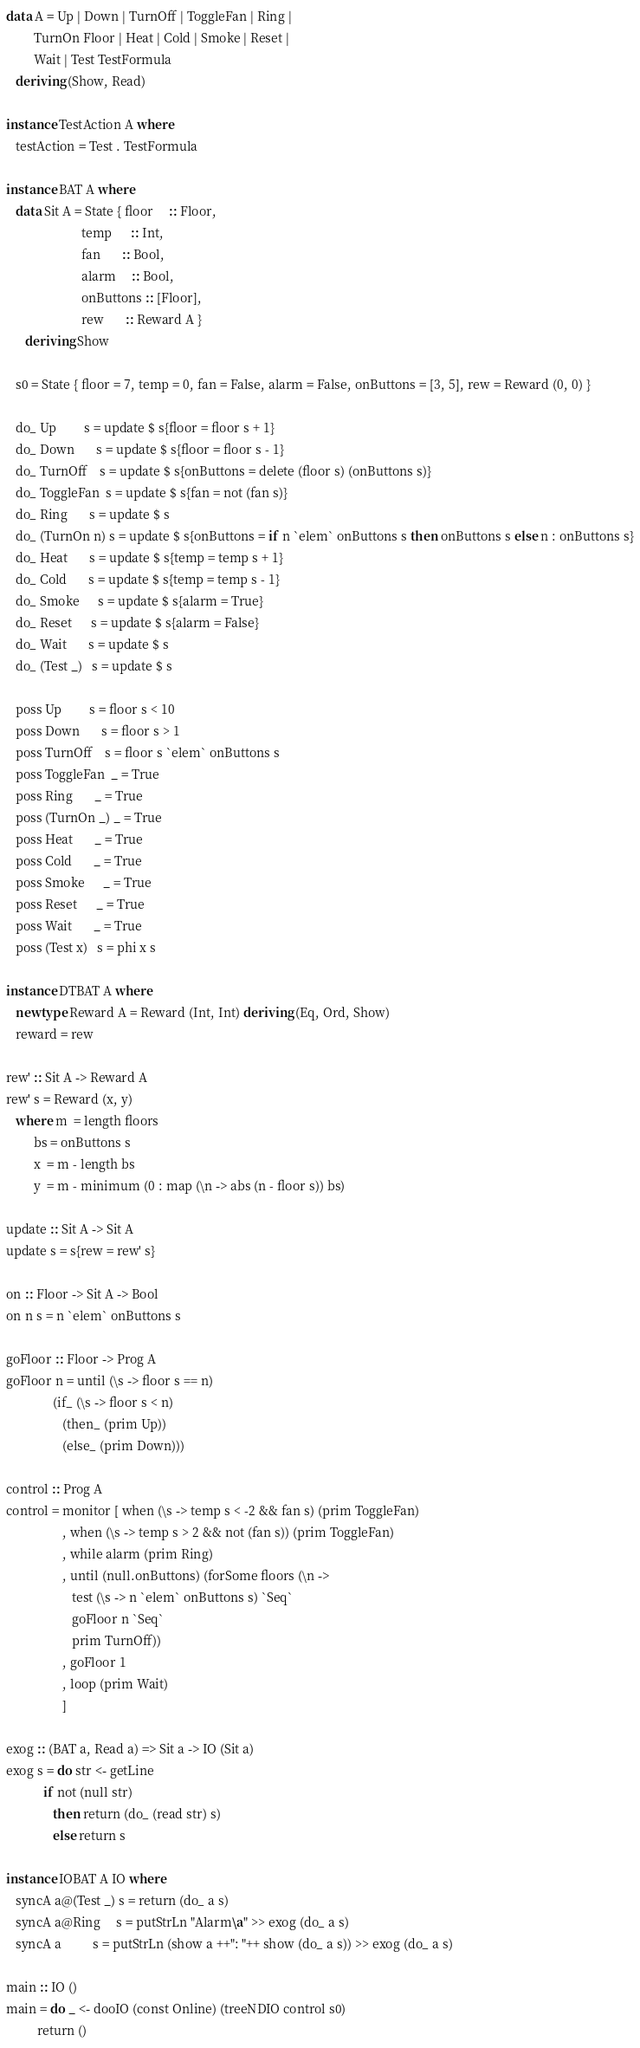Convert code to text. <code><loc_0><loc_0><loc_500><loc_500><_Haskell_>
data A = Up | Down | TurnOff | ToggleFan | Ring |
         TurnOn Floor | Heat | Cold | Smoke | Reset |
         Wait | Test TestFormula
   deriving (Show, Read)

instance TestAction A where
   testAction = Test . TestFormula

instance BAT A where
   data Sit A = State { floor     :: Floor,
                        temp      :: Int,
                        fan       :: Bool,
                        alarm     :: Bool,
                        onButtons :: [Floor],
                        rew       :: Reward A }
      deriving Show

   s0 = State { floor = 7, temp = 0, fan = False, alarm = False, onButtons = [3, 5], rew = Reward (0, 0) }

   do_ Up         s = update $ s{floor = floor s + 1}
   do_ Down       s = update $ s{floor = floor s - 1}
   do_ TurnOff    s = update $ s{onButtons = delete (floor s) (onButtons s)}
   do_ ToggleFan  s = update $ s{fan = not (fan s)}
   do_ Ring       s = update $ s
   do_ (TurnOn n) s = update $ s{onButtons = if n `elem` onButtons s then onButtons s else n : onButtons s}
   do_ Heat       s = update $ s{temp = temp s + 1}
   do_ Cold       s = update $ s{temp = temp s - 1}
   do_ Smoke      s = update $ s{alarm = True}
   do_ Reset      s = update $ s{alarm = False}
   do_ Wait       s = update $ s
   do_ (Test _)   s = update $ s

   poss Up         s = floor s < 10
   poss Down       s = floor s > 1
   poss TurnOff    s = floor s `elem` onButtons s
   poss ToggleFan  _ = True
   poss Ring       _ = True
   poss (TurnOn _) _ = True
   poss Heat       _ = True
   poss Cold       _ = True
   poss Smoke      _ = True
   poss Reset      _ = True
   poss Wait       _ = True
   poss (Test x)   s = phi x s

instance DTBAT A where
   newtype Reward A = Reward (Int, Int) deriving (Eq, Ord, Show)
   reward = rew

rew' :: Sit A -> Reward A
rew' s = Reward (x, y)
   where m  = length floors
         bs = onButtons s
         x  = m - length bs
         y  = m - minimum (0 : map (\n -> abs (n - floor s)) bs)

update :: Sit A -> Sit A
update s = s{rew = rew' s}

on :: Floor -> Sit A -> Bool
on n s = n `elem` onButtons s

goFloor :: Floor -> Prog A
goFloor n = until (\s -> floor s == n)
               (if_ (\s -> floor s < n)
                  (then_ (prim Up))
                  (else_ (prim Down)))

control :: Prog A
control = monitor [ when (\s -> temp s < -2 && fan s) (prim ToggleFan)
                  , when (\s -> temp s > 2 && not (fan s)) (prim ToggleFan)
                  , while alarm (prim Ring)
                  , until (null.onButtons) (forSome floors (\n ->
                     test (\s -> n `elem` onButtons s) `Seq`
                     goFloor n `Seq`
                     prim TurnOff))
                  , goFloor 1
                  , loop (prim Wait)
                  ]

exog :: (BAT a, Read a) => Sit a -> IO (Sit a)
exog s = do str <- getLine
            if not (null str)
               then return (do_ (read str) s)
               else return s

instance IOBAT A IO where
   syncA a@(Test _) s = return (do_ a s)
   syncA a@Ring     s = putStrLn "Alarm\a" >> exog (do_ a s)
   syncA a          s = putStrLn (show a ++": "++ show (do_ a s)) >> exog (do_ a s)

main :: IO ()
main = do _ <- dooIO (const Online) (treeNDIO control s0)
          return ()

</code> 